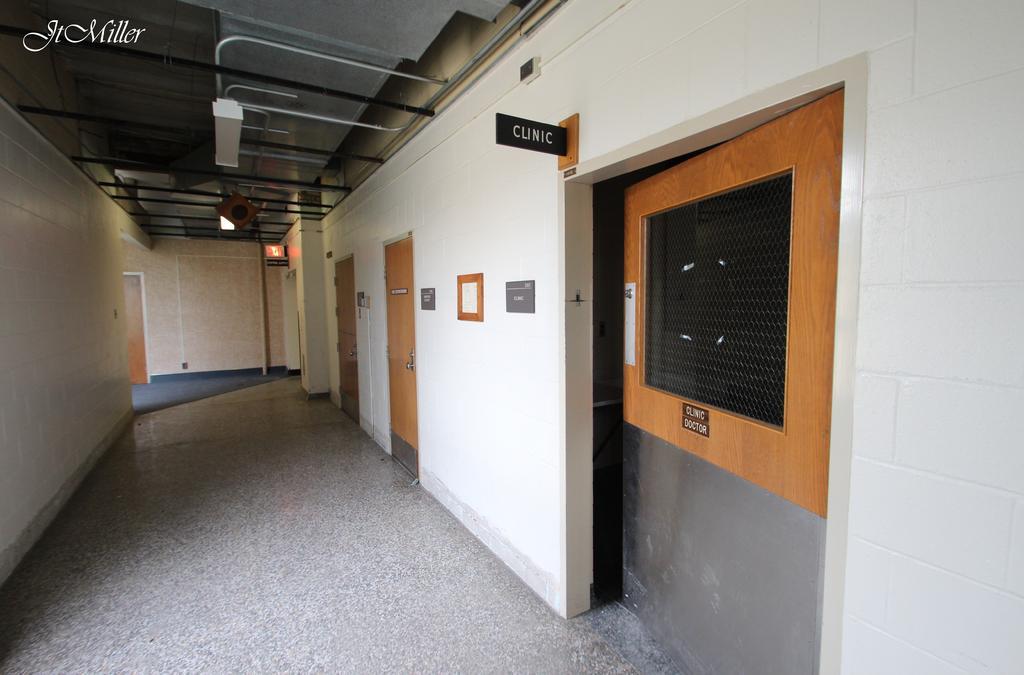In one or two sentences, can you explain what this image depicts? This picture shows inner view of a building we see few doors and name boards to the wall and and few boards fixed to the wall and a frame and we see watermark on the top left corner. 